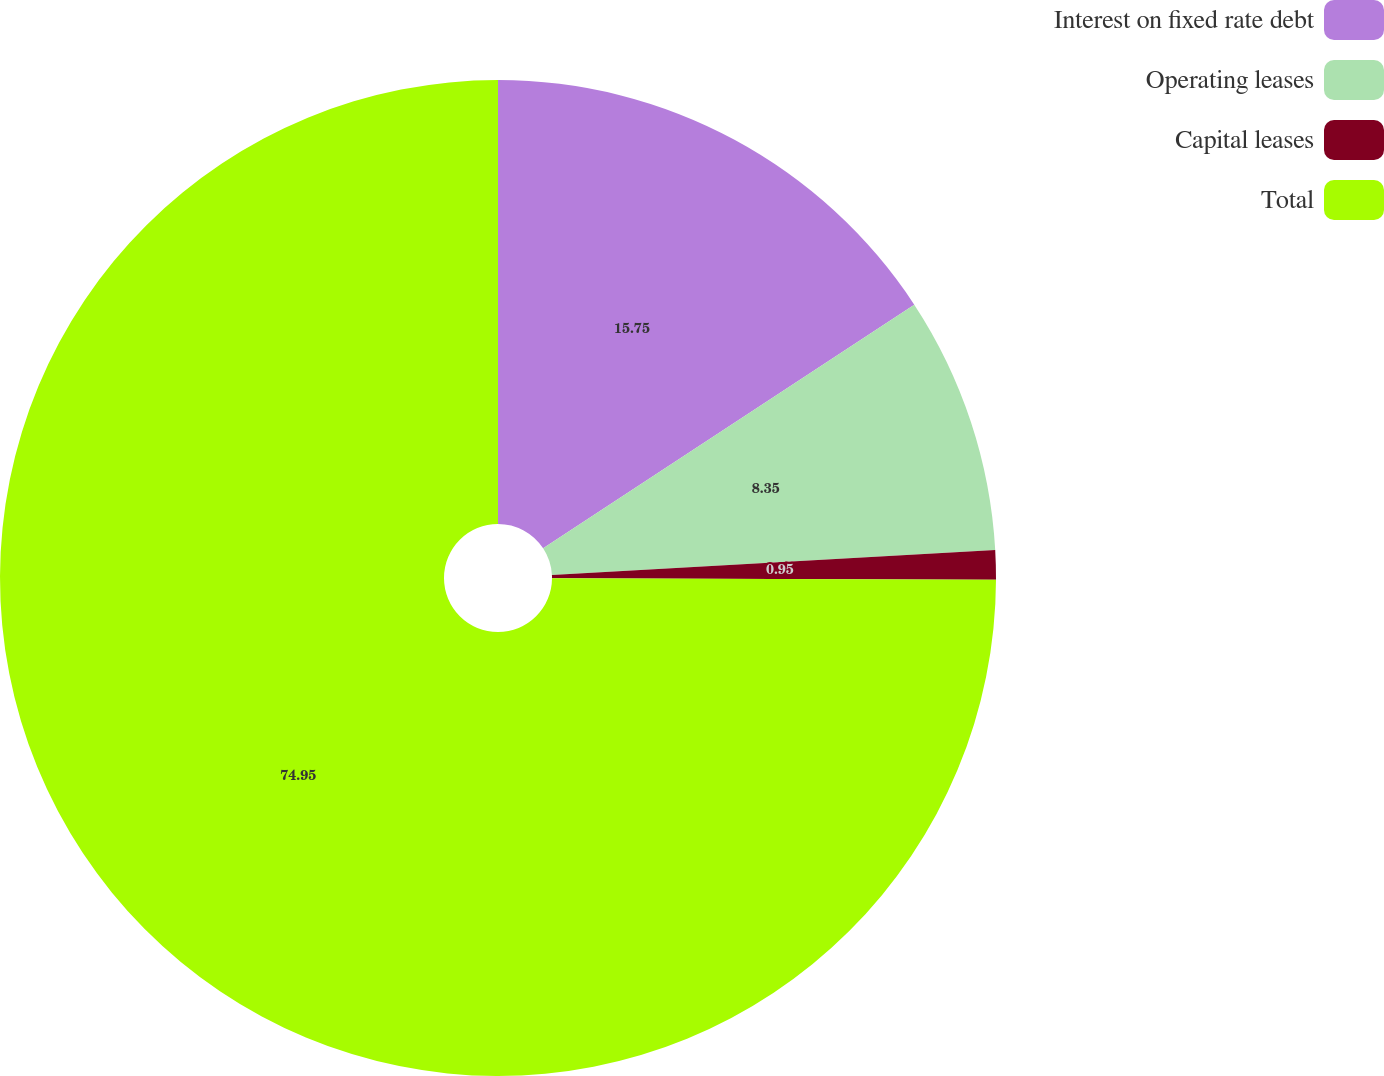Convert chart to OTSL. <chart><loc_0><loc_0><loc_500><loc_500><pie_chart><fcel>Interest on fixed rate debt<fcel>Operating leases<fcel>Capital leases<fcel>Total<nl><fcel>15.75%<fcel>8.35%<fcel>0.95%<fcel>74.94%<nl></chart> 